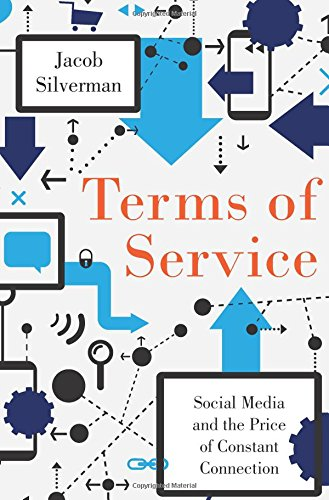Who is the author of this book? The author of the book depicted in the image is Jacob Silverman, known for his keen insights on social media's effects on society. 